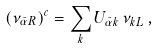<formula> <loc_0><loc_0><loc_500><loc_500>( \nu _ { \bar { \alpha } R } ) ^ { c } = \sum _ { k } U _ { \bar { \alpha } k } \, \nu _ { k L } \, ,</formula> 